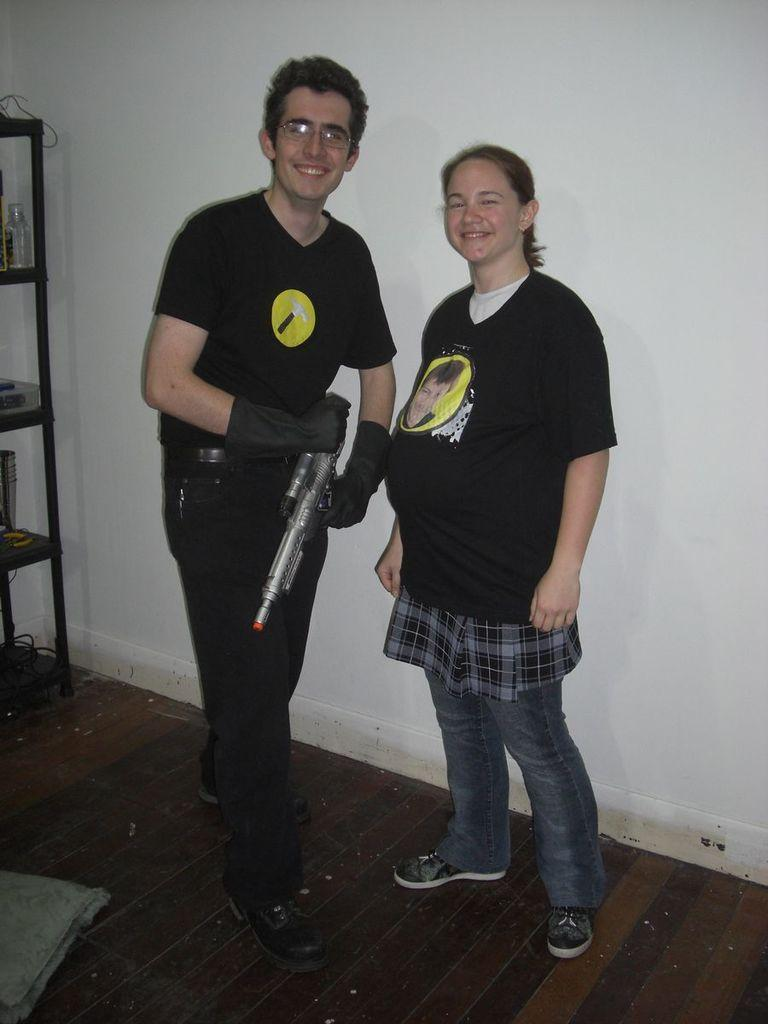How many people are in the image? There are two people in the image, a man and a woman. What are the man and woman doing in the image? The man and woman are standing together. What can be seen on the shelf in the image? The shelf has many things on it. What type of flesh can be seen on the seashore in the image? There is no seashore or flesh present in the image. 